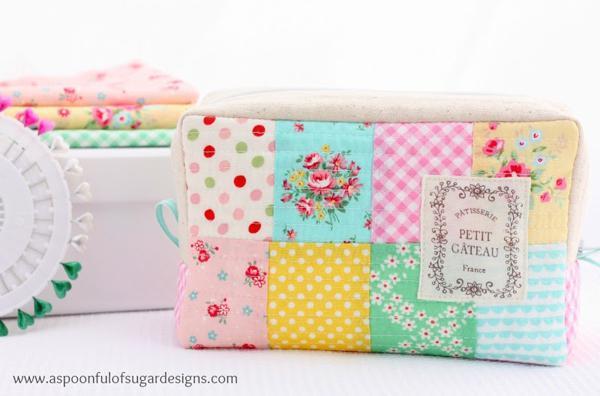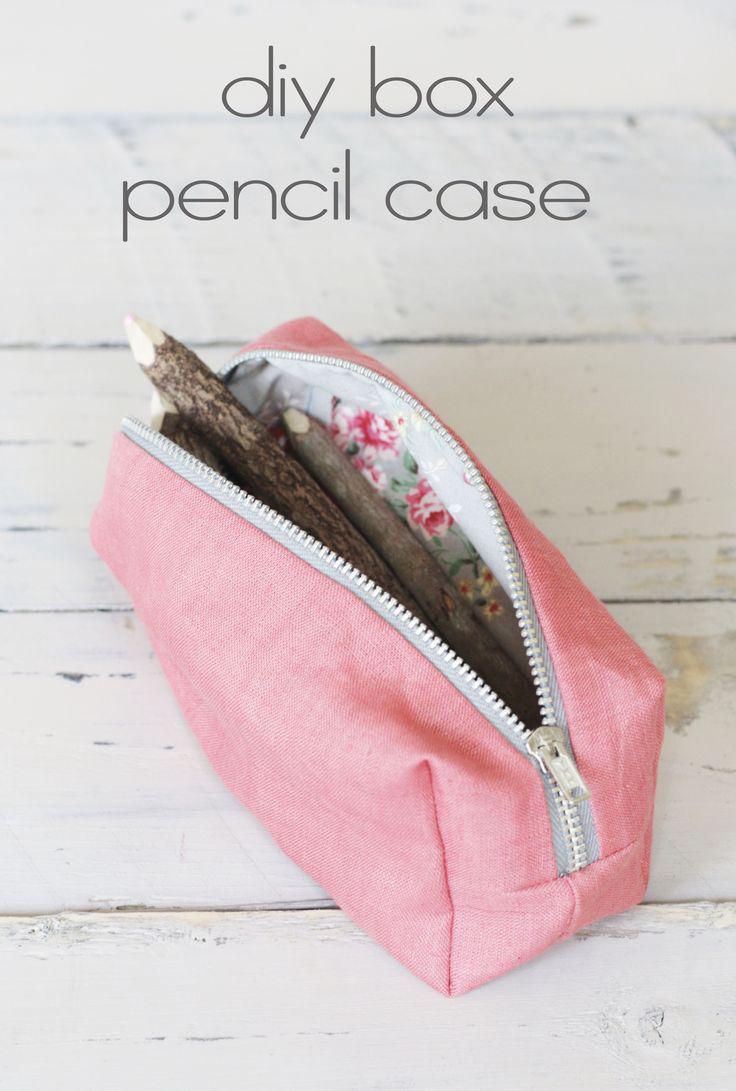The first image is the image on the left, the second image is the image on the right. For the images displayed, is the sentence "There is a zipper in the image on the right." factually correct? Answer yes or no. Yes. 